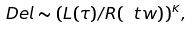Convert formula to latex. <formula><loc_0><loc_0><loc_500><loc_500>\ D e l \sim ( L ( \tau ) / R ( \ t w ) ) ^ { \kappa } ,</formula> 